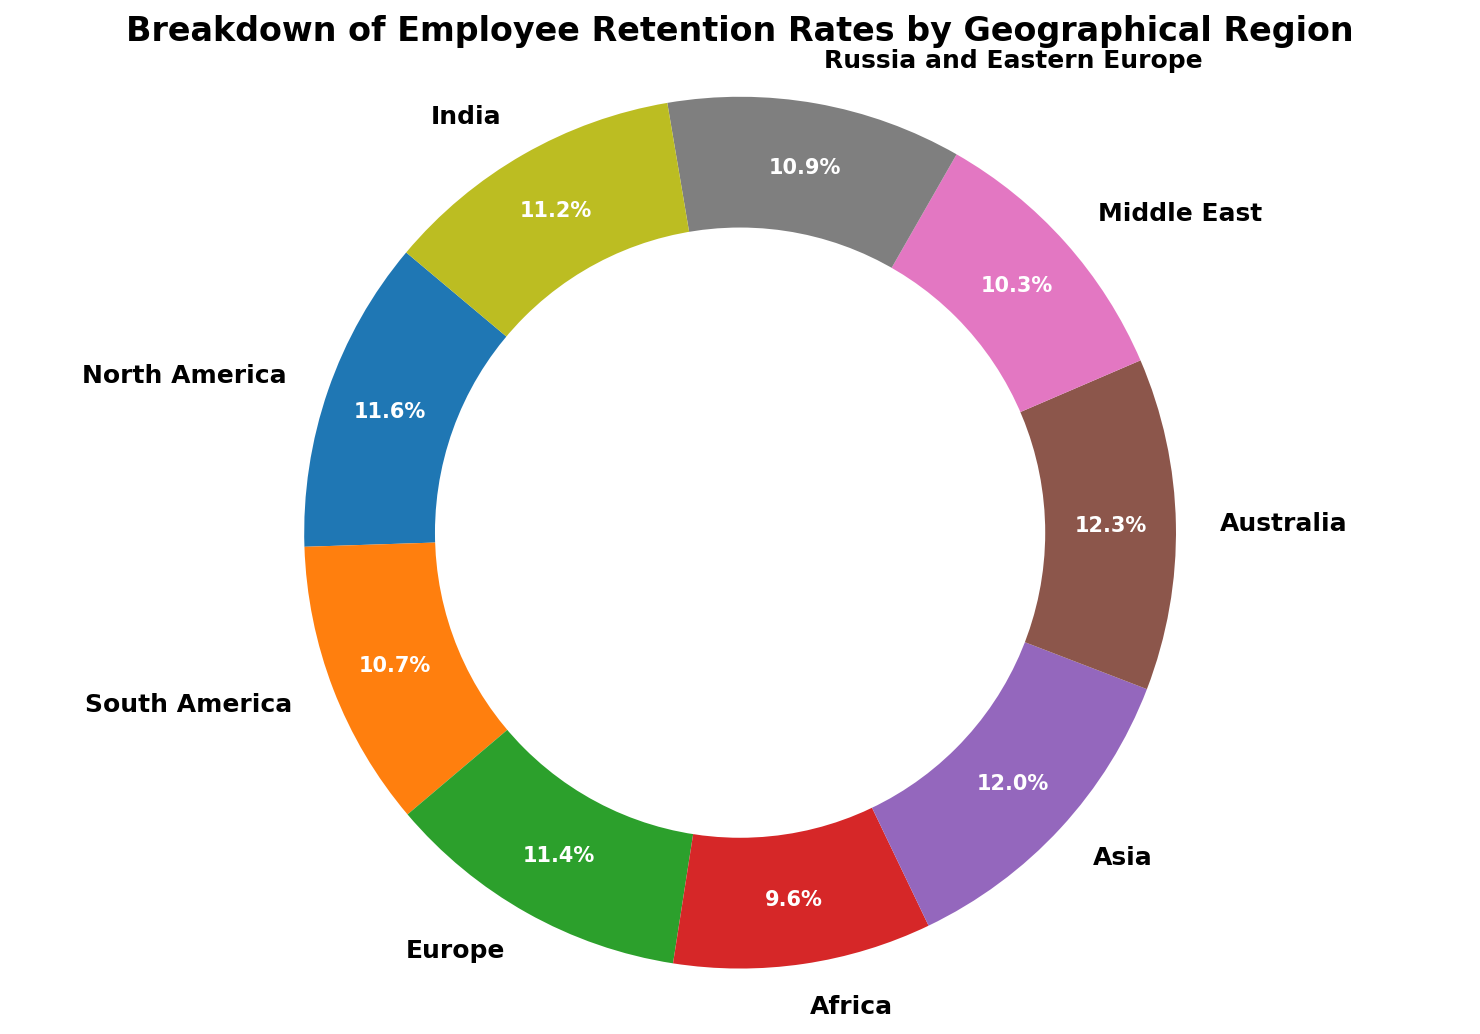What region has the highest employee retention rate? By examining the ring chart, the segment with the largest percentage label can be identified. Visually, the segment for "Australia" stands out with a retention rate of 90%, which is the highest.
Answer: Australia What is the combined retention rate for North America and Europe? The retention rates for North America and Europe are 85% and 83%, respectively. Summing these values gives 85 + 83 = 168%.
Answer: 168% Which region has a lower retention rate, Africa or Middle East? By comparing the segments labeled "Africa" and "Middle East", we can see that Africa has a retention rate of 70% and the Middle East has 75%. Since 70% is less than 75%, Africa has the lower retention rate.
Answer: Africa What is the average retention rate for South America, Russia and Eastern Europe, and India? The retention rates for South America, Russia and Eastern Europe, and India are 78%, 80%, and 82%, respectively. Adding these values gives a total of 78 + 80 + 82 = 240. Dividing by the number of regions (3) gives an average retention rate of 240 / 3 = 80%.
Answer: 80% How much higher is Asia's retention rate compared to Africa's? Asia's retention rate is 88% and Africa's is 70%. Subtracting the retention rate of Africa from Asia's, 88 - 70, gives a difference of 18%.
Answer: 18% Which regions have retention rates that are 80% or higher? By examining the ring chart, the segments belonging to North America (85%), Europe (83%), Asia (88%), Australia (90%), Russia and Eastern Europe (80%), and India (82%) all have retention rates of 80% or higher.
Answer: North America, Europe, Asia, Australia, Russia and Eastern Europe, India Is there any region that has a retention rate equal to 75%? The segment labeled "Middle East" shows a retention rate of exactly 75%.
Answer: Middle East Does North America have a higher retention rate than India? North America's retention rate is 85% and India's is 82%. Since 85% is greater than 82%, North America has a higher retention rate than India.
Answer: Yes What is the difference between the highest and lowest retention rates? The highest retention rate is in Australia at 90%, and the lowest is in Africa at 70%. The difference between these two rates is 90 - 70 = 20%.
Answer: 20% What is the retention rate of Europe, and how does it compare to that of Asia? Europe's retention rate is 83% and Asia's is 88%. Comparing these two rates, Asia's retention rate is higher.
Answer: Europe's retention rate is 83%, Asia's is higher 